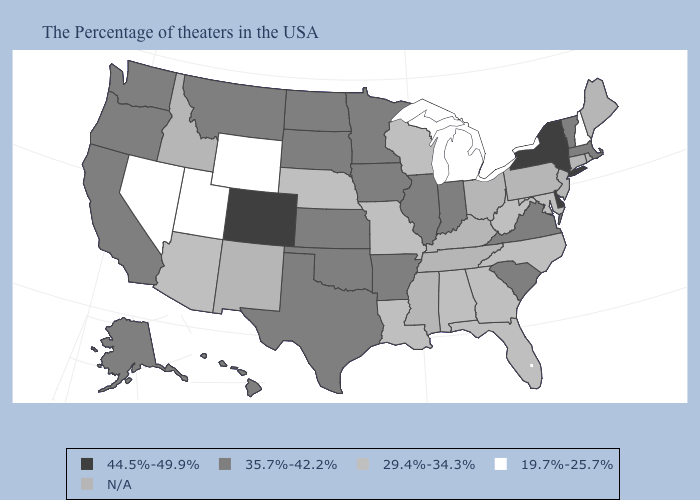What is the highest value in states that border Oklahoma?
Be succinct. 44.5%-49.9%. How many symbols are there in the legend?
Answer briefly. 5. Name the states that have a value in the range 44.5%-49.9%?
Concise answer only. New York, Delaware, Colorado. Name the states that have a value in the range 44.5%-49.9%?
Be succinct. New York, Delaware, Colorado. Which states have the lowest value in the MidWest?
Be succinct. Michigan. Does Alaska have the lowest value in the USA?
Answer briefly. No. What is the lowest value in the Northeast?
Write a very short answer. 19.7%-25.7%. What is the value of Oklahoma?
Keep it brief. 35.7%-42.2%. Does Minnesota have the highest value in the MidWest?
Quick response, please. Yes. Which states have the lowest value in the USA?
Short answer required. New Hampshire, Michigan, Wyoming, Utah, Nevada. Does Alaska have the highest value in the USA?
Write a very short answer. No. What is the value of Michigan?
Quick response, please. 19.7%-25.7%. Is the legend a continuous bar?
Short answer required. No. What is the value of Connecticut?
Short answer required. N/A. 